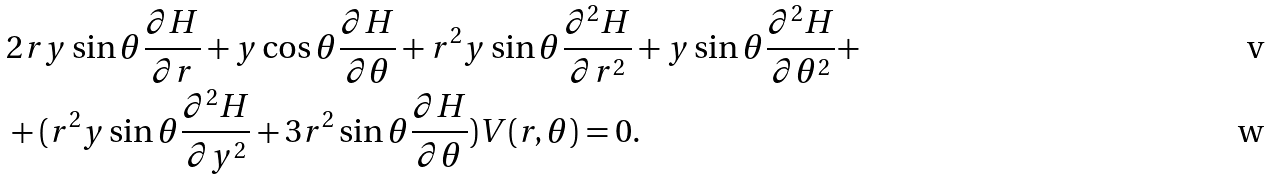<formula> <loc_0><loc_0><loc_500><loc_500>& 2 r y \sin \theta \frac { \partial H } { \partial r } + y \cos \theta \frac { \partial H } { \partial \theta } + r ^ { 2 } y \sin \theta \frac { \partial ^ { 2 } H } { \partial r ^ { 2 } } + y \sin \theta \frac { \partial ^ { 2 } H } { \partial \theta ^ { 2 } } + \\ & + ( r ^ { 2 } y \sin \theta \frac { \partial ^ { 2 } H } { \partial y ^ { 2 } } + 3 r ^ { 2 } \sin \theta \frac { \partial H } { \partial \theta } ) V ( r , \theta ) = 0 .</formula> 